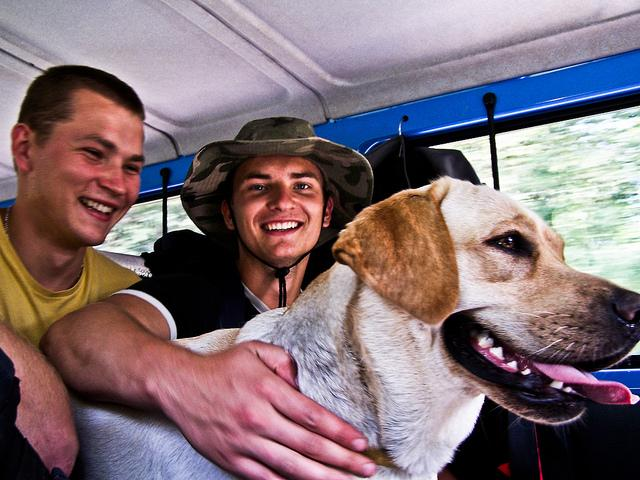What is touching the dog? Please explain your reasoning. man's hand. A man's hand is draped around the dog, hugging it. 